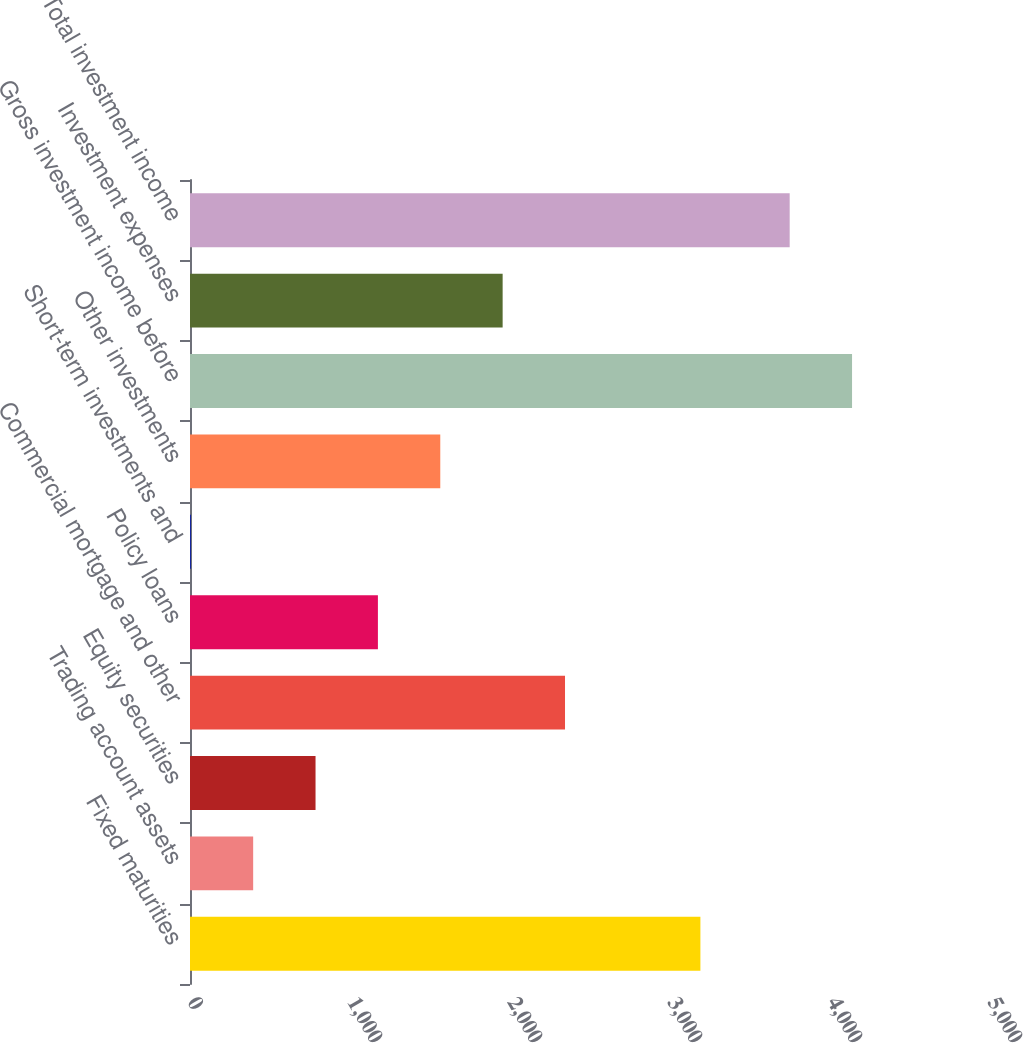Convert chart to OTSL. <chart><loc_0><loc_0><loc_500><loc_500><bar_chart><fcel>Fixed maturities<fcel>Trading account assets<fcel>Equity securities<fcel>Commercial mortgage and other<fcel>Policy loans<fcel>Short-term investments and<fcel>Other investments<fcel>Gross investment income before<fcel>Investment expenses<fcel>Total investment income<nl><fcel>3190<fcel>394.8<fcel>784.6<fcel>2343.8<fcel>1174.4<fcel>5<fcel>1564.2<fcel>4137.8<fcel>1954<fcel>3748<nl></chart> 